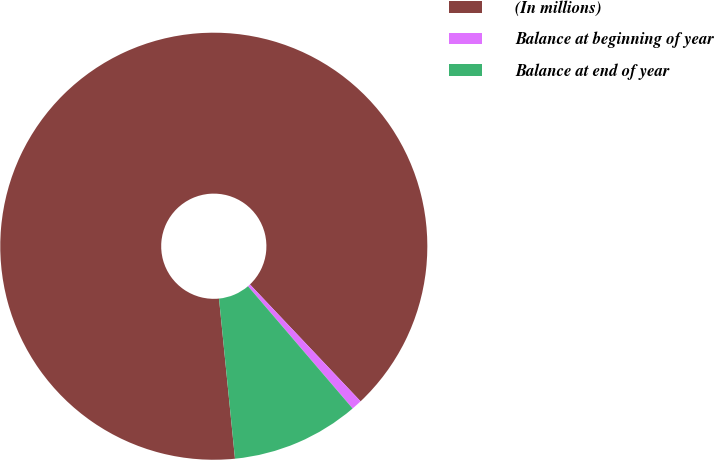Convert chart to OTSL. <chart><loc_0><loc_0><loc_500><loc_500><pie_chart><fcel>(In millions)<fcel>Balance at beginning of year<fcel>Balance at end of year<nl><fcel>89.52%<fcel>0.8%<fcel>9.68%<nl></chart> 